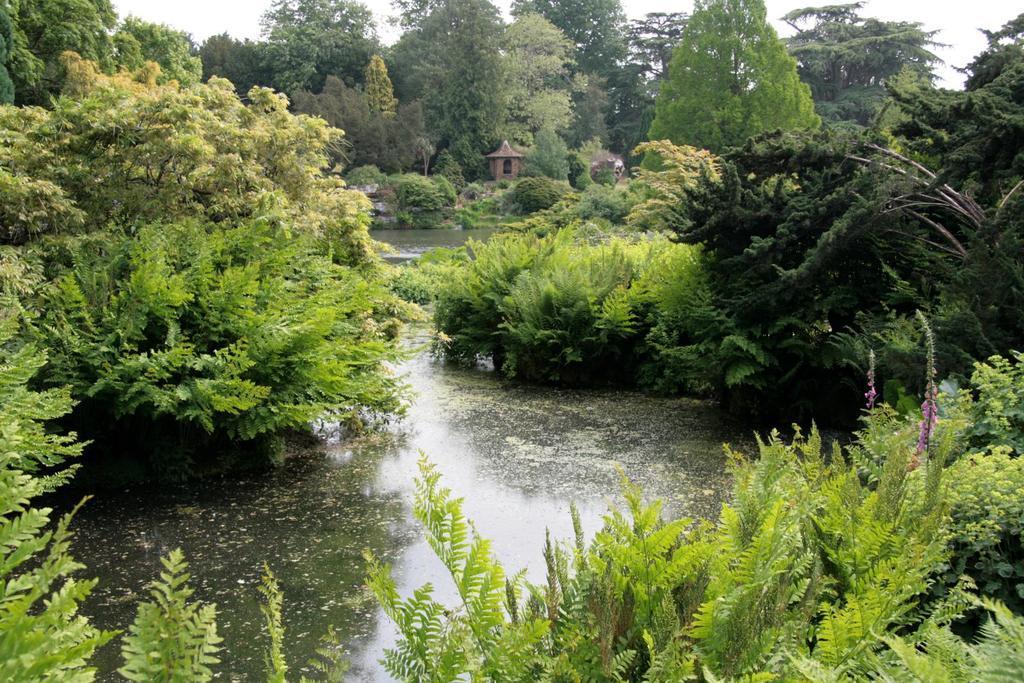Please provide a concise description of this image. In this picture we can see the water. There are a few bushes, some objects and trees are visible in the background. 